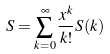<formula> <loc_0><loc_0><loc_500><loc_500>S = \sum _ { k = 0 } ^ { \infty } \frac { x ^ { k } } { k ! } S ( k )</formula> 